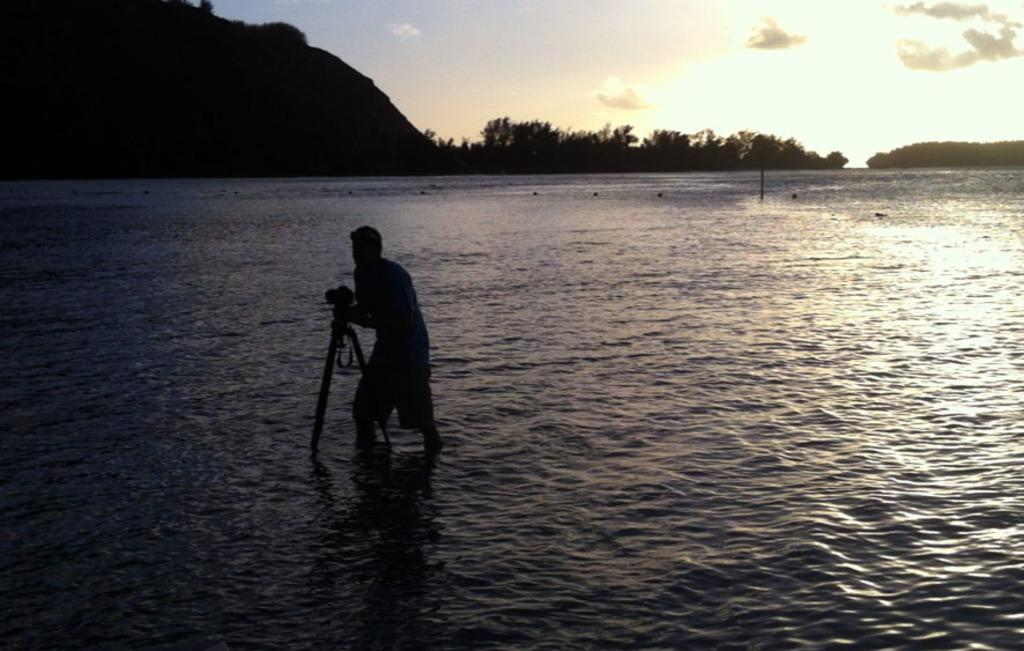What can be seen in the image? There is a person in the image. What is the person holding in their hands? The person is holding something in their hands. What natural element is visible in the image? There is water visible in the image. What can be seen in the distance in the image? The sky is visible in the background of the image. How would you describe the lighting in the image? The background appears to be dark. What type of fog can be seen in the image? There is no fog present in the image; it features a person holding something, water, and a dark background. 